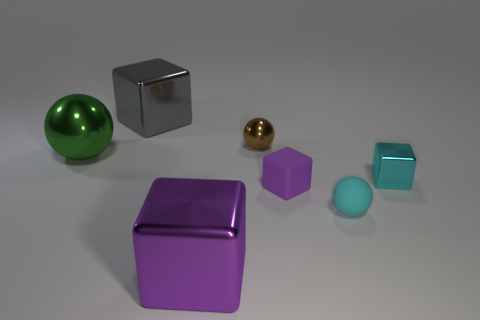How many brown objects are small matte cylinders or small metal spheres?
Make the answer very short. 1. Are there any other things that have the same material as the small brown sphere?
Your answer should be compact. Yes. There is a brown object that is the same shape as the large green thing; what is it made of?
Offer a terse response. Metal. Are there the same number of gray cubes that are in front of the tiny purple thing and large gray matte things?
Provide a short and direct response. Yes. There is a metal block that is behind the tiny cyan sphere and to the left of the tiny cyan rubber ball; what size is it?
Provide a succinct answer. Large. Is there anything else that is the same color as the small metal cube?
Provide a succinct answer. Yes. There is a purple block that is to the right of the purple object left of the small brown metal object; how big is it?
Provide a succinct answer. Small. The block that is both in front of the tiny cyan metallic block and right of the brown metallic object is what color?
Ensure brevity in your answer.  Purple. What number of other objects are there of the same size as the rubber block?
Offer a terse response. 3. Do the cyan metal object and the shiny sphere that is to the right of the gray block have the same size?
Your answer should be compact. Yes. 